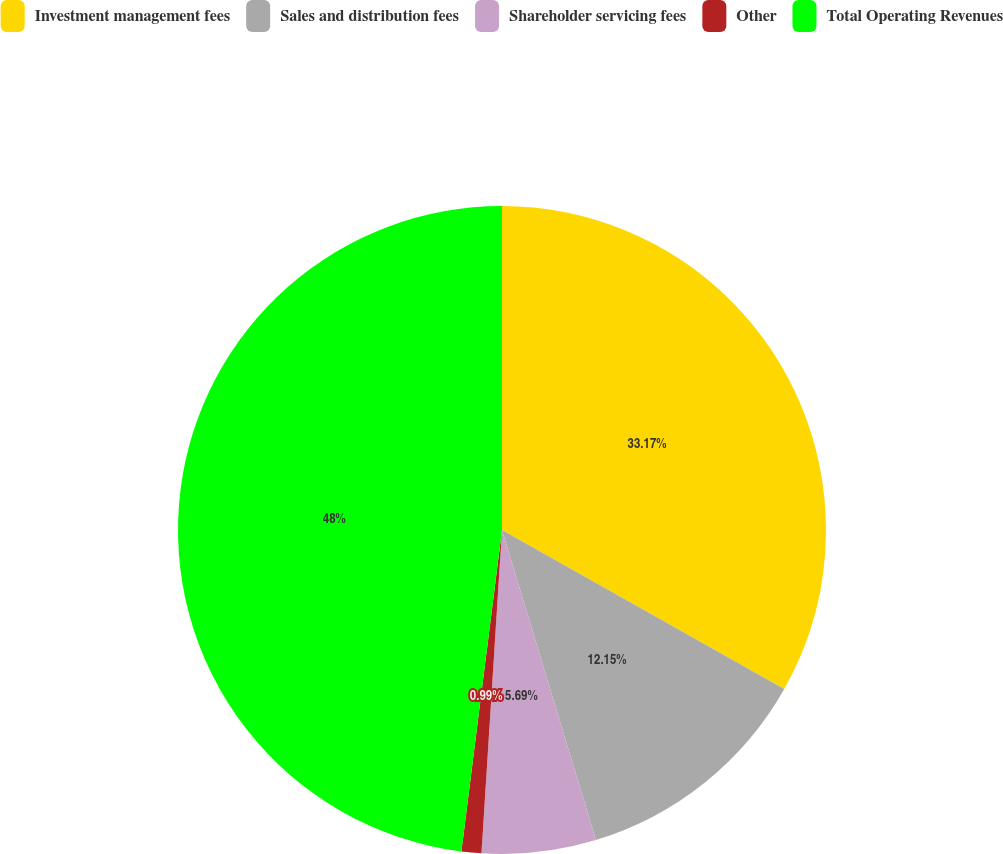Convert chart to OTSL. <chart><loc_0><loc_0><loc_500><loc_500><pie_chart><fcel>Investment management fees<fcel>Sales and distribution fees<fcel>Shareholder servicing fees<fcel>Other<fcel>Total Operating Revenues<nl><fcel>33.17%<fcel>12.15%<fcel>5.69%<fcel>0.99%<fcel>48.0%<nl></chart> 